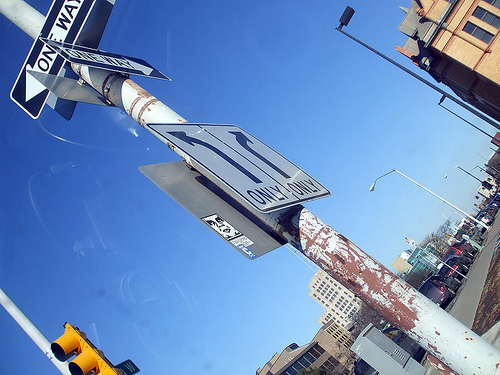Extract all visible text content from this image. ONLY ONLY ONE WAY ONE WAY 